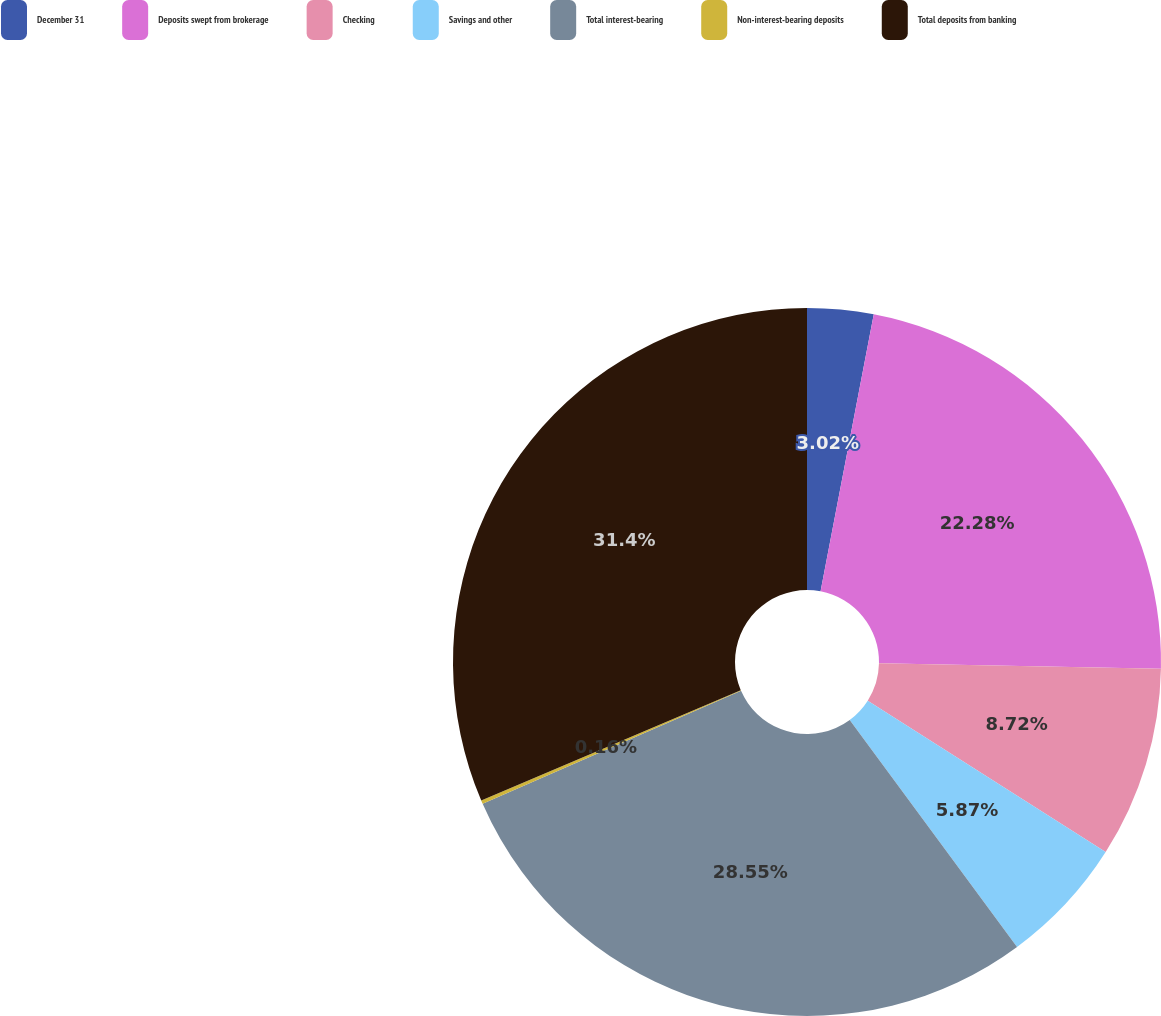Convert chart. <chart><loc_0><loc_0><loc_500><loc_500><pie_chart><fcel>December 31<fcel>Deposits swept from brokerage<fcel>Checking<fcel>Savings and other<fcel>Total interest-bearing<fcel>Non-interest-bearing deposits<fcel>Total deposits from banking<nl><fcel>3.02%<fcel>22.28%<fcel>8.72%<fcel>5.87%<fcel>28.55%<fcel>0.16%<fcel>31.4%<nl></chart> 